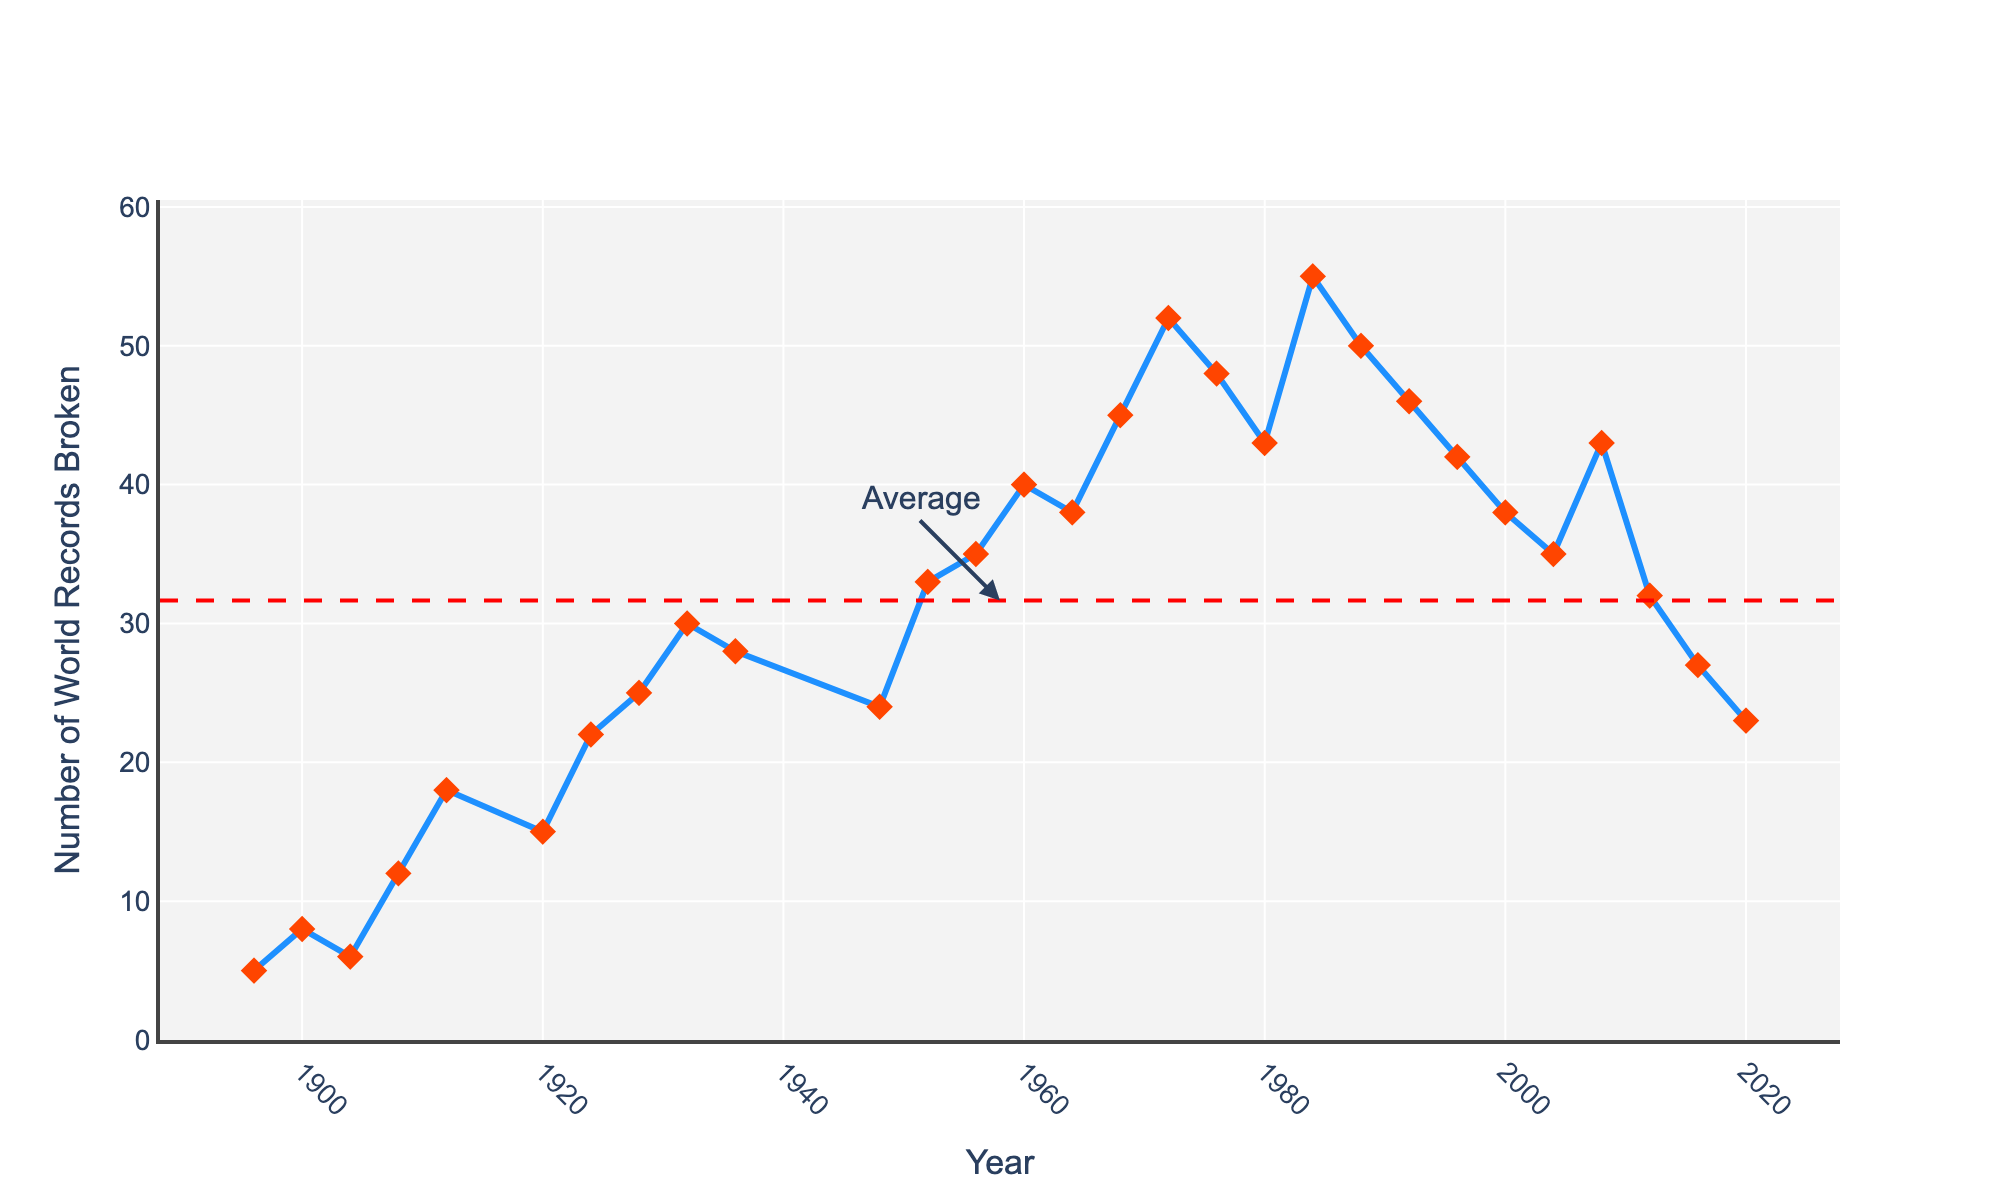How many world records were broken in 1912? Refer to the data point corresponding to the year 1912 on the x-axis and check the y-axis value for that point; the value is 18.
Answer: 18 Which year had the highest number of world records broken? Find the point with the highest y-axis value on the line chart, which corresponds to the year 1984 with 55 world records broken.
Answer: 1984 How many more world records were broken in 1956 compared to 1912? Check the y-axis values for 1956 and 1912, which are 35 and 18, respectively. Subtract 18 from 35 to find the difference.
Answer: 17 What is the average number of world records broken per year, as indicated by the dashed red line? The dashed red line represents the average. Based on the chart annotations, the average value is identified.
Answer: Average In which years did the number of world records broken exceed the average? Identify the years where the y-values exceed the value of the red dashed line. These include years like 1968, 1972, 1984, etc.
Answer: (List the specific years exceeding the average) How did the number of world records broken change between 1936 and 1948? Compare the y-axis values for 1936 (28) and 1948 (24). The number decreased by 4 records.
Answer: -4 What visual marker is used to display data points on this line chart? Look at the design of the markers on the line chart; they are diamond-shaped and red in color.
Answer: Diamond What trend do you observe in the number of world records broken from 1960 to 1972? Observe the line chart from 1960 to 1972; the number of records generally increases, peaking at 1972 with 52 records.
Answer: Increasing trend By how much did the number of world records broken decrease from 1972 to 1976? Compare the values on the y-axis for 1972 (52) and 1976 (48). Subtract 48 from 52 to find the decrease.
Answer: 4 Which year had fewer world records broken: 2000 or 2004? Compare the y-axis values for 2000 (38) and 2004 (35). The year 2004 had fewer records broken.
Answer: 2004 